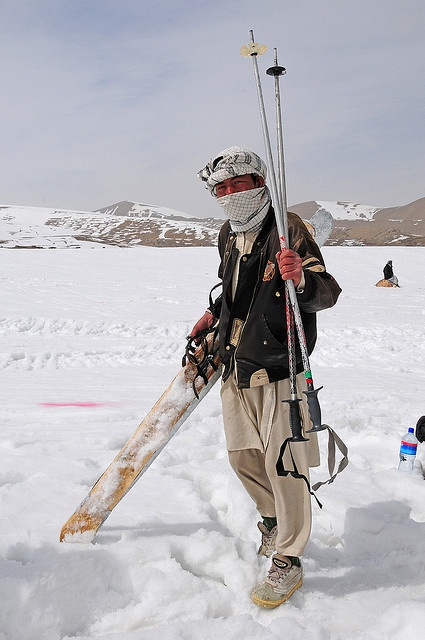Describe the objects in this image and their specific colors. I can see people in darkgray, black, and gray tones, skis in darkgray, lightgray, and tan tones, bottle in darkgray, lightgray, blue, and lightblue tones, and people in darkgray, black, gray, and lightgray tones in this image. 